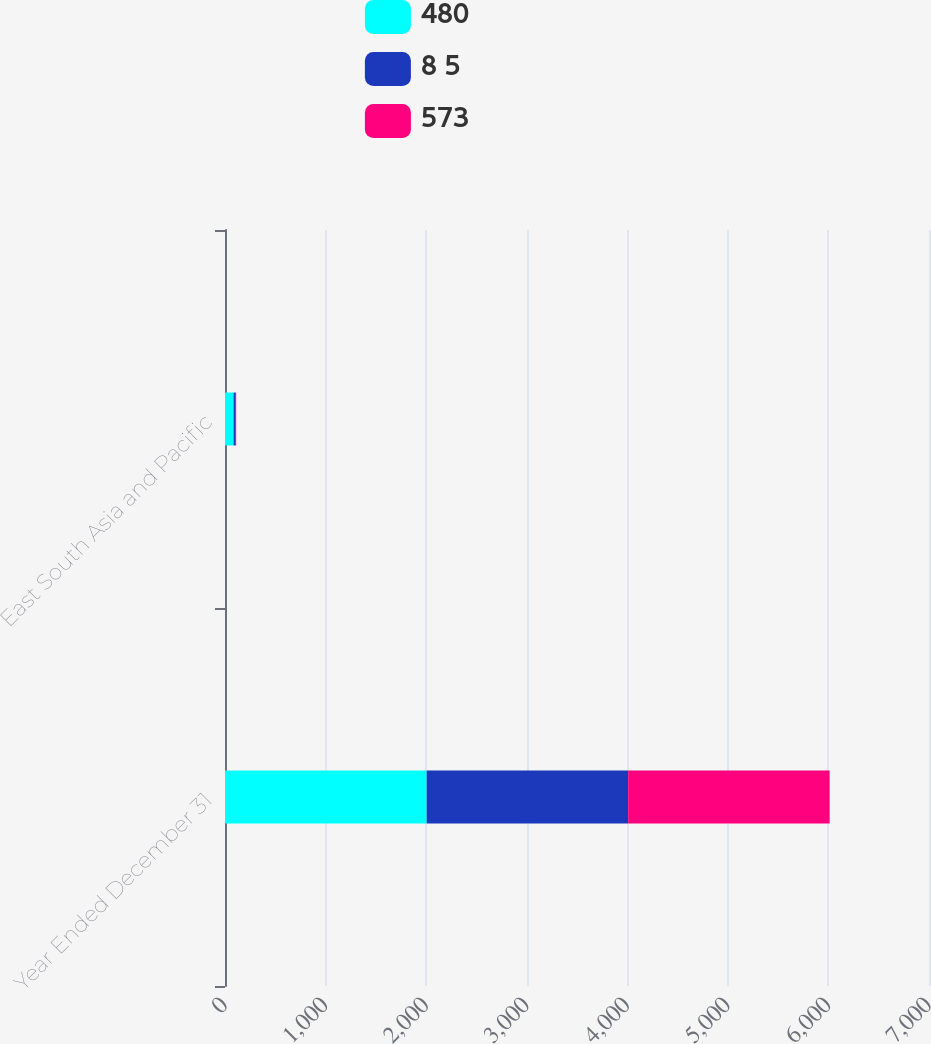Convert chart. <chart><loc_0><loc_0><loc_500><loc_500><stacked_bar_chart><ecel><fcel>Year Ended December 31<fcel>East South Asia and Pacific<nl><fcel>480<fcel>2005<fcel>85<nl><fcel>8 5<fcel>2004<fcel>15<nl><fcel>573<fcel>2003<fcel>11<nl></chart> 